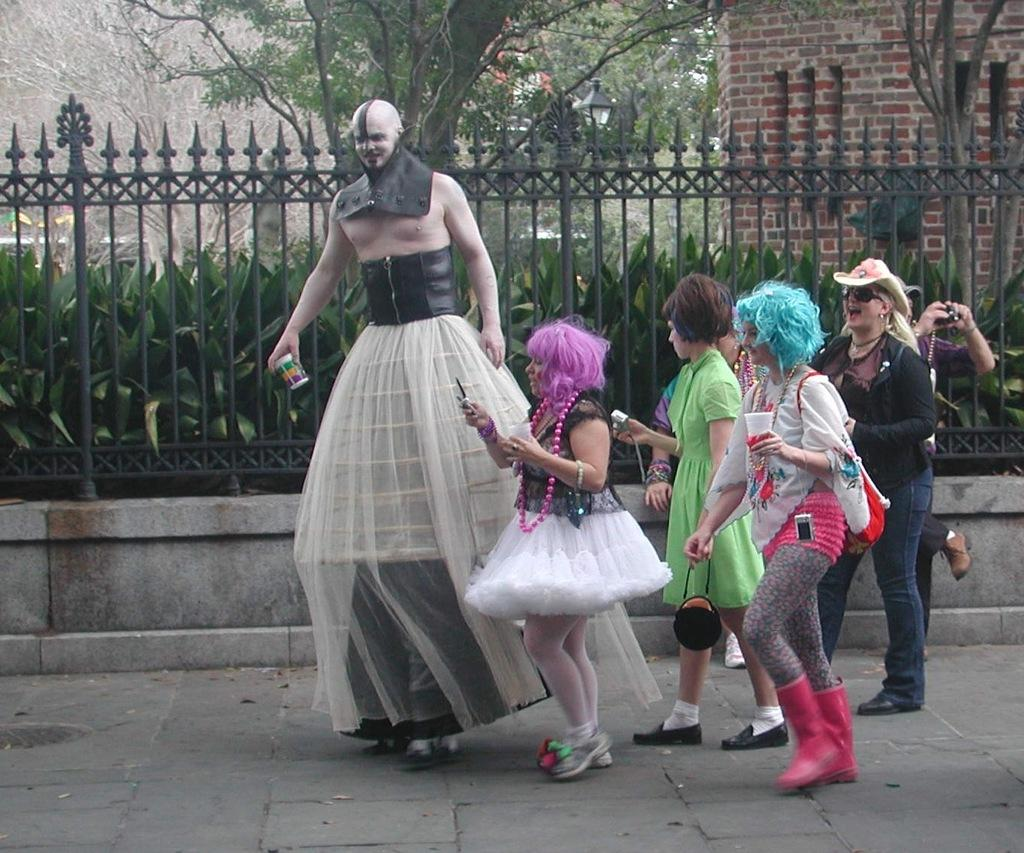What are the persons in the image wearing? The persons in the image are wearing costumes. Where are the persons standing in the image? The persons are standing on the floor. What can be seen in the background of the image? There are trees, walls, a street light, plants, and an iron grill visible in the background of the image. What type of meal is being served at the zoo in the image? There is no zoo or meal present in the image; it features persons wearing costumes standing on the floor with a background that includes trees, walls, a street light, plants, and an iron grill. --- Facts: 1. There is a person holding a book in the image. 2. The person is sitting on a chair. 3. There is a table in the image. 4. The table has a lamp on it. 5. There is a window in the background of the image. 6. The window has curtains. Absurd Topics: parrot, bicycle, ocean Conversation: What is the person in the image holding? The person in the image is holding a book. Where is the person sitting in the image? The person is sitting on a chair. What can be seen on the table in the image? The table has a lamp on it. What is visible in the background of the image? There is a window with curtains in the background of the image. Reasoning: Let's think step by step in order to produce the conversation. We start by identifying the main subject in the image, which is the person holding a book. Then, we describe their location, which is sitting on a chair. Next, we expand the conversation to include the table and its lamp, as well as the window and its curtains in the background. Each question is designed to elicit a specific detail about the image that is known from the provided facts. Absurd Question/Answer: Can you see a parrot flying near the ocean in the image? There is no parrot or ocean present in the image; it features a person holding a book, sitting on a chair, with a table that has a lamp on it, and a window with curtains in the background. 